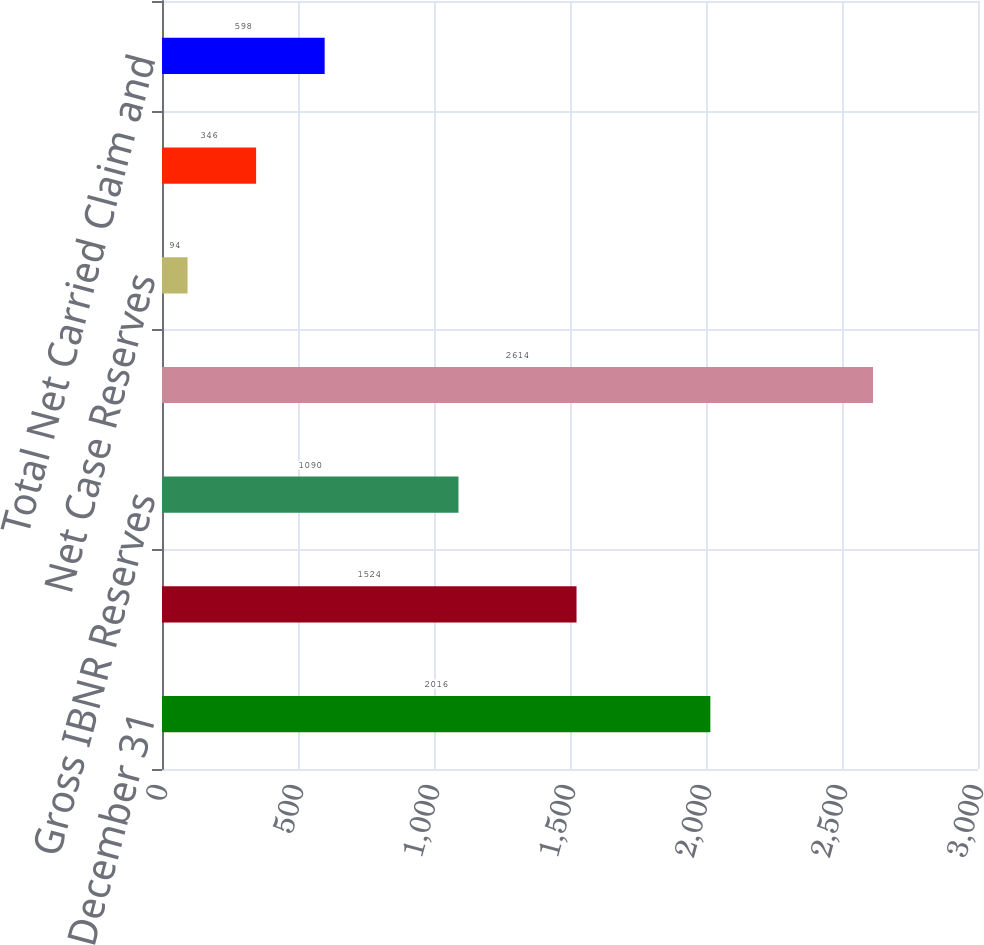Convert chart to OTSL. <chart><loc_0><loc_0><loc_500><loc_500><bar_chart><fcel>December 31<fcel>Gross Case Reserves<fcel>Gross IBNR Reserves<fcel>Total Gross Carried Claim and<fcel>Net Case Reserves<fcel>Net IBNR Reserves<fcel>Total Net Carried Claim and<nl><fcel>2016<fcel>1524<fcel>1090<fcel>2614<fcel>94<fcel>346<fcel>598<nl></chart> 